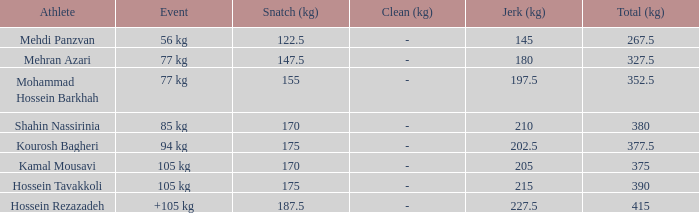What is the total that had an event of +105 kg and clean & jerk less than 227.5? 0.0. 